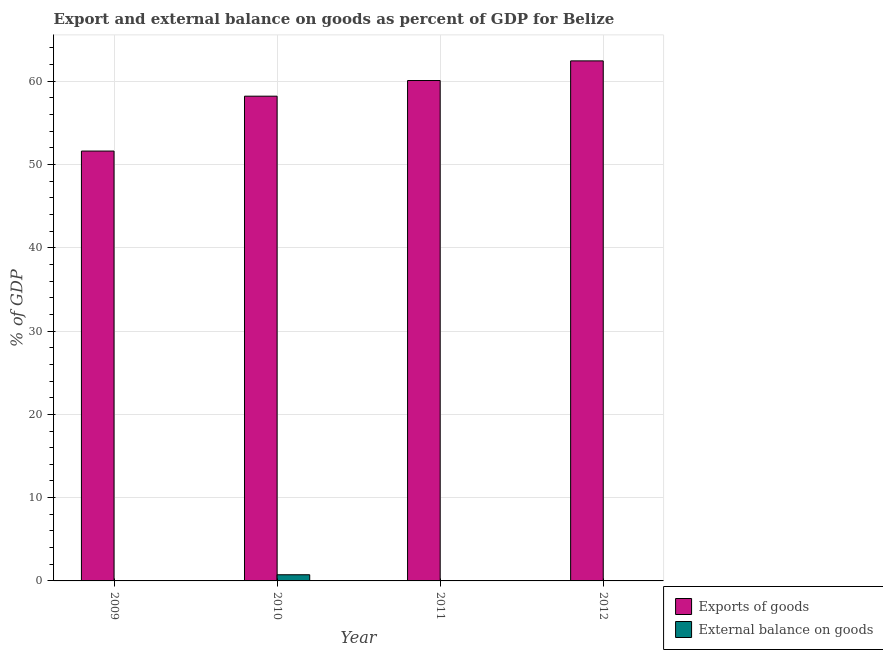How many different coloured bars are there?
Provide a succinct answer. 2. Are the number of bars per tick equal to the number of legend labels?
Provide a succinct answer. No. Are the number of bars on each tick of the X-axis equal?
Ensure brevity in your answer.  No. What is the external balance on goods as percentage of gdp in 2010?
Your answer should be compact. 0.74. Across all years, what is the maximum external balance on goods as percentage of gdp?
Offer a very short reply. 0.74. In which year was the export of goods as percentage of gdp maximum?
Provide a short and direct response. 2012. What is the total export of goods as percentage of gdp in the graph?
Ensure brevity in your answer.  232.38. What is the difference between the export of goods as percentage of gdp in 2010 and that in 2011?
Give a very brief answer. -1.88. What is the difference between the export of goods as percentage of gdp in 2011 and the external balance on goods as percentage of gdp in 2010?
Provide a short and direct response. 1.88. What is the average export of goods as percentage of gdp per year?
Offer a very short reply. 58.1. In how many years, is the external balance on goods as percentage of gdp greater than 40 %?
Offer a terse response. 0. What is the ratio of the export of goods as percentage of gdp in 2010 to that in 2012?
Your response must be concise. 0.93. What is the difference between the highest and the second highest export of goods as percentage of gdp?
Your answer should be very brief. 2.36. What is the difference between the highest and the lowest export of goods as percentage of gdp?
Give a very brief answer. 10.83. How many bars are there?
Keep it short and to the point. 5. Are all the bars in the graph horizontal?
Give a very brief answer. No. How many years are there in the graph?
Your answer should be very brief. 4. What is the difference between two consecutive major ticks on the Y-axis?
Keep it short and to the point. 10. Are the values on the major ticks of Y-axis written in scientific E-notation?
Your response must be concise. No. Where does the legend appear in the graph?
Give a very brief answer. Bottom right. How are the legend labels stacked?
Keep it short and to the point. Vertical. What is the title of the graph?
Offer a terse response. Export and external balance on goods as percent of GDP for Belize. Does "Net savings(excluding particulate emission damage)" appear as one of the legend labels in the graph?
Ensure brevity in your answer.  No. What is the label or title of the Y-axis?
Keep it short and to the point. % of GDP. What is the % of GDP of Exports of goods in 2009?
Provide a short and direct response. 51.62. What is the % of GDP of Exports of goods in 2010?
Your answer should be compact. 58.21. What is the % of GDP in External balance on goods in 2010?
Make the answer very short. 0.74. What is the % of GDP in Exports of goods in 2011?
Provide a short and direct response. 60.09. What is the % of GDP of External balance on goods in 2011?
Offer a very short reply. 0. What is the % of GDP in Exports of goods in 2012?
Your answer should be compact. 62.45. Across all years, what is the maximum % of GDP in Exports of goods?
Keep it short and to the point. 62.45. Across all years, what is the maximum % of GDP in External balance on goods?
Provide a succinct answer. 0.74. Across all years, what is the minimum % of GDP of Exports of goods?
Your answer should be compact. 51.62. What is the total % of GDP of Exports of goods in the graph?
Offer a very short reply. 232.38. What is the total % of GDP in External balance on goods in the graph?
Your answer should be very brief. 0.74. What is the difference between the % of GDP in Exports of goods in 2009 and that in 2010?
Offer a very short reply. -6.59. What is the difference between the % of GDP of Exports of goods in 2009 and that in 2011?
Keep it short and to the point. -8.47. What is the difference between the % of GDP in Exports of goods in 2009 and that in 2012?
Provide a short and direct response. -10.83. What is the difference between the % of GDP of Exports of goods in 2010 and that in 2011?
Ensure brevity in your answer.  -1.88. What is the difference between the % of GDP in Exports of goods in 2010 and that in 2012?
Give a very brief answer. -4.24. What is the difference between the % of GDP in Exports of goods in 2011 and that in 2012?
Offer a terse response. -2.36. What is the difference between the % of GDP in Exports of goods in 2009 and the % of GDP in External balance on goods in 2010?
Give a very brief answer. 50.88. What is the average % of GDP in Exports of goods per year?
Keep it short and to the point. 58.1. What is the average % of GDP of External balance on goods per year?
Provide a succinct answer. 0.19. In the year 2010, what is the difference between the % of GDP in Exports of goods and % of GDP in External balance on goods?
Your answer should be compact. 57.47. What is the ratio of the % of GDP of Exports of goods in 2009 to that in 2010?
Your response must be concise. 0.89. What is the ratio of the % of GDP in Exports of goods in 2009 to that in 2011?
Keep it short and to the point. 0.86. What is the ratio of the % of GDP of Exports of goods in 2009 to that in 2012?
Offer a very short reply. 0.83. What is the ratio of the % of GDP of Exports of goods in 2010 to that in 2011?
Make the answer very short. 0.97. What is the ratio of the % of GDP in Exports of goods in 2010 to that in 2012?
Offer a very short reply. 0.93. What is the ratio of the % of GDP of Exports of goods in 2011 to that in 2012?
Give a very brief answer. 0.96. What is the difference between the highest and the second highest % of GDP of Exports of goods?
Ensure brevity in your answer.  2.36. What is the difference between the highest and the lowest % of GDP of Exports of goods?
Make the answer very short. 10.83. What is the difference between the highest and the lowest % of GDP in External balance on goods?
Provide a succinct answer. 0.74. 